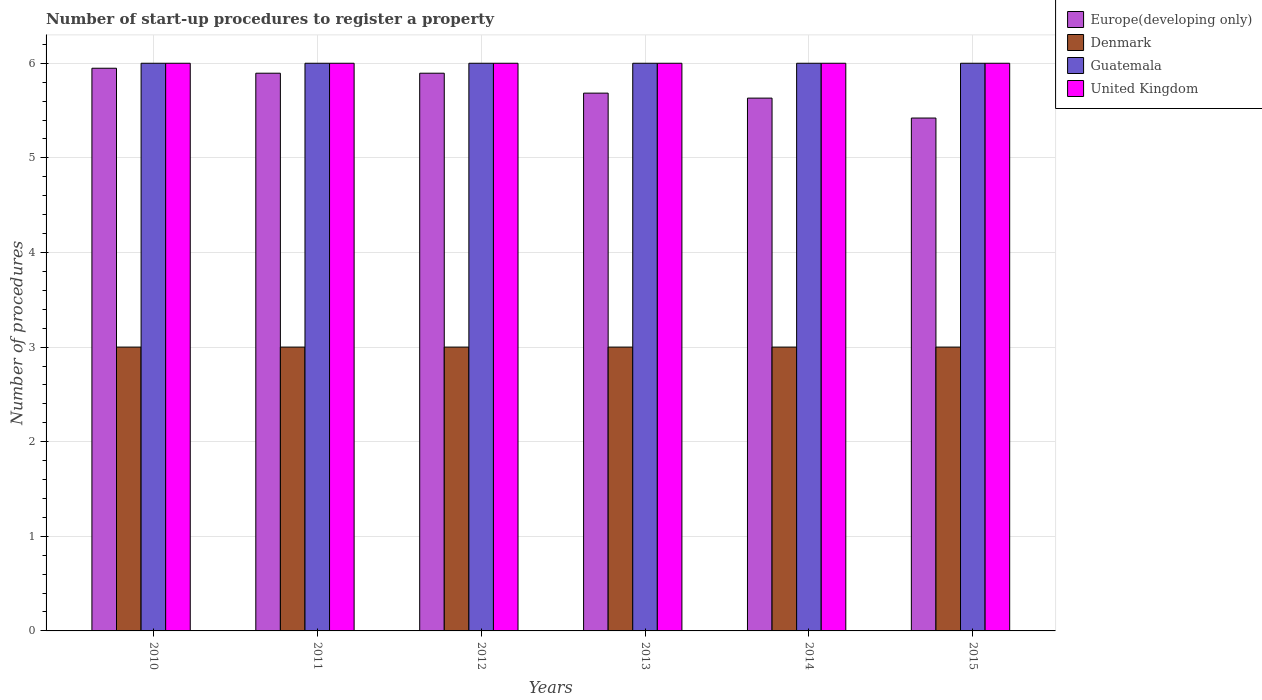How many different coloured bars are there?
Your answer should be very brief. 4. How many groups of bars are there?
Keep it short and to the point. 6. Are the number of bars per tick equal to the number of legend labels?
Ensure brevity in your answer.  Yes. How many bars are there on the 5th tick from the left?
Your answer should be very brief. 4. How many bars are there on the 4th tick from the right?
Provide a short and direct response. 4. In how many cases, is the number of bars for a given year not equal to the number of legend labels?
Provide a short and direct response. 0. What is the number of procedures required to register a property in Denmark in 2012?
Ensure brevity in your answer.  3. Across all years, what is the maximum number of procedures required to register a property in Europe(developing only)?
Your answer should be compact. 5.95. Across all years, what is the minimum number of procedures required to register a property in Europe(developing only)?
Offer a terse response. 5.42. In which year was the number of procedures required to register a property in Guatemala maximum?
Keep it short and to the point. 2010. In which year was the number of procedures required to register a property in Europe(developing only) minimum?
Your answer should be very brief. 2015. What is the total number of procedures required to register a property in Denmark in the graph?
Provide a short and direct response. 18. What is the difference between the number of procedures required to register a property in Europe(developing only) in 2015 and the number of procedures required to register a property in Denmark in 2013?
Your answer should be compact. 2.42. In the year 2010, what is the difference between the number of procedures required to register a property in Denmark and number of procedures required to register a property in Europe(developing only)?
Your answer should be compact. -2.95. What is the ratio of the number of procedures required to register a property in Guatemala in 2012 to that in 2014?
Provide a short and direct response. 1. Is the difference between the number of procedures required to register a property in Denmark in 2013 and 2015 greater than the difference between the number of procedures required to register a property in Europe(developing only) in 2013 and 2015?
Keep it short and to the point. No. What is the difference between the highest and the second highest number of procedures required to register a property in Europe(developing only)?
Your answer should be compact. 0.05. Is the sum of the number of procedures required to register a property in Europe(developing only) in 2011 and 2015 greater than the maximum number of procedures required to register a property in United Kingdom across all years?
Make the answer very short. Yes. Is it the case that in every year, the sum of the number of procedures required to register a property in Guatemala and number of procedures required to register a property in Denmark is greater than the sum of number of procedures required to register a property in Europe(developing only) and number of procedures required to register a property in United Kingdom?
Your answer should be compact. No. What does the 2nd bar from the right in 2014 represents?
Make the answer very short. Guatemala. How many bars are there?
Give a very brief answer. 24. Are all the bars in the graph horizontal?
Ensure brevity in your answer.  No. How many years are there in the graph?
Your answer should be compact. 6. What is the difference between two consecutive major ticks on the Y-axis?
Provide a succinct answer. 1. Does the graph contain any zero values?
Your response must be concise. No. Does the graph contain grids?
Make the answer very short. Yes. How many legend labels are there?
Provide a succinct answer. 4. How are the legend labels stacked?
Provide a short and direct response. Vertical. What is the title of the graph?
Give a very brief answer. Number of start-up procedures to register a property. What is the label or title of the Y-axis?
Provide a short and direct response. Number of procedures. What is the Number of procedures in Europe(developing only) in 2010?
Ensure brevity in your answer.  5.95. What is the Number of procedures of Denmark in 2010?
Ensure brevity in your answer.  3. What is the Number of procedures in Guatemala in 2010?
Give a very brief answer. 6. What is the Number of procedures in United Kingdom in 2010?
Offer a terse response. 6. What is the Number of procedures of Europe(developing only) in 2011?
Your response must be concise. 5.89. What is the Number of procedures of Guatemala in 2011?
Your answer should be very brief. 6. What is the Number of procedures of United Kingdom in 2011?
Keep it short and to the point. 6. What is the Number of procedures in Europe(developing only) in 2012?
Offer a very short reply. 5.89. What is the Number of procedures in Guatemala in 2012?
Your answer should be very brief. 6. What is the Number of procedures in Europe(developing only) in 2013?
Ensure brevity in your answer.  5.68. What is the Number of procedures in Denmark in 2013?
Make the answer very short. 3. What is the Number of procedures of Europe(developing only) in 2014?
Offer a terse response. 5.63. What is the Number of procedures in United Kingdom in 2014?
Your response must be concise. 6. What is the Number of procedures of Europe(developing only) in 2015?
Make the answer very short. 5.42. What is the Number of procedures in Denmark in 2015?
Your response must be concise. 3. Across all years, what is the maximum Number of procedures in Europe(developing only)?
Provide a short and direct response. 5.95. Across all years, what is the maximum Number of procedures in Guatemala?
Your answer should be very brief. 6. Across all years, what is the maximum Number of procedures of United Kingdom?
Make the answer very short. 6. Across all years, what is the minimum Number of procedures in Europe(developing only)?
Provide a short and direct response. 5.42. Across all years, what is the minimum Number of procedures of Guatemala?
Your response must be concise. 6. Across all years, what is the minimum Number of procedures in United Kingdom?
Your response must be concise. 6. What is the total Number of procedures of Europe(developing only) in the graph?
Your answer should be very brief. 34.47. What is the total Number of procedures in Denmark in the graph?
Ensure brevity in your answer.  18. What is the total Number of procedures of Guatemala in the graph?
Offer a very short reply. 36. What is the total Number of procedures in United Kingdom in the graph?
Make the answer very short. 36. What is the difference between the Number of procedures in Europe(developing only) in 2010 and that in 2011?
Provide a short and direct response. 0.05. What is the difference between the Number of procedures of Guatemala in 2010 and that in 2011?
Offer a very short reply. 0. What is the difference between the Number of procedures of Europe(developing only) in 2010 and that in 2012?
Ensure brevity in your answer.  0.05. What is the difference between the Number of procedures of United Kingdom in 2010 and that in 2012?
Your answer should be very brief. 0. What is the difference between the Number of procedures of Europe(developing only) in 2010 and that in 2013?
Provide a succinct answer. 0.26. What is the difference between the Number of procedures in Denmark in 2010 and that in 2013?
Offer a very short reply. 0. What is the difference between the Number of procedures of Europe(developing only) in 2010 and that in 2014?
Offer a terse response. 0.32. What is the difference between the Number of procedures in Denmark in 2010 and that in 2014?
Provide a short and direct response. 0. What is the difference between the Number of procedures in Guatemala in 2010 and that in 2014?
Offer a very short reply. 0. What is the difference between the Number of procedures in United Kingdom in 2010 and that in 2014?
Provide a short and direct response. 0. What is the difference between the Number of procedures in Europe(developing only) in 2010 and that in 2015?
Your response must be concise. 0.53. What is the difference between the Number of procedures in Denmark in 2010 and that in 2015?
Make the answer very short. 0. What is the difference between the Number of procedures in Guatemala in 2010 and that in 2015?
Your response must be concise. 0. What is the difference between the Number of procedures in Denmark in 2011 and that in 2012?
Ensure brevity in your answer.  0. What is the difference between the Number of procedures in Guatemala in 2011 and that in 2012?
Your answer should be compact. 0. What is the difference between the Number of procedures of United Kingdom in 2011 and that in 2012?
Give a very brief answer. 0. What is the difference between the Number of procedures in Europe(developing only) in 2011 and that in 2013?
Ensure brevity in your answer.  0.21. What is the difference between the Number of procedures of Guatemala in 2011 and that in 2013?
Ensure brevity in your answer.  0. What is the difference between the Number of procedures of United Kingdom in 2011 and that in 2013?
Give a very brief answer. 0. What is the difference between the Number of procedures in Europe(developing only) in 2011 and that in 2014?
Give a very brief answer. 0.26. What is the difference between the Number of procedures in Denmark in 2011 and that in 2014?
Ensure brevity in your answer.  0. What is the difference between the Number of procedures in Guatemala in 2011 and that in 2014?
Make the answer very short. 0. What is the difference between the Number of procedures in Europe(developing only) in 2011 and that in 2015?
Give a very brief answer. 0.47. What is the difference between the Number of procedures of Guatemala in 2011 and that in 2015?
Make the answer very short. 0. What is the difference between the Number of procedures of Europe(developing only) in 2012 and that in 2013?
Your answer should be compact. 0.21. What is the difference between the Number of procedures in Europe(developing only) in 2012 and that in 2014?
Ensure brevity in your answer.  0.26. What is the difference between the Number of procedures of Denmark in 2012 and that in 2014?
Provide a short and direct response. 0. What is the difference between the Number of procedures in Guatemala in 2012 and that in 2014?
Your response must be concise. 0. What is the difference between the Number of procedures in United Kingdom in 2012 and that in 2014?
Your answer should be compact. 0. What is the difference between the Number of procedures in Europe(developing only) in 2012 and that in 2015?
Make the answer very short. 0.47. What is the difference between the Number of procedures of United Kingdom in 2012 and that in 2015?
Your answer should be very brief. 0. What is the difference between the Number of procedures of Europe(developing only) in 2013 and that in 2014?
Your answer should be very brief. 0.05. What is the difference between the Number of procedures of Denmark in 2013 and that in 2014?
Give a very brief answer. 0. What is the difference between the Number of procedures in United Kingdom in 2013 and that in 2014?
Provide a short and direct response. 0. What is the difference between the Number of procedures of Europe(developing only) in 2013 and that in 2015?
Provide a short and direct response. 0.26. What is the difference between the Number of procedures in Guatemala in 2013 and that in 2015?
Give a very brief answer. 0. What is the difference between the Number of procedures of Europe(developing only) in 2014 and that in 2015?
Give a very brief answer. 0.21. What is the difference between the Number of procedures of Denmark in 2014 and that in 2015?
Give a very brief answer. 0. What is the difference between the Number of procedures of Europe(developing only) in 2010 and the Number of procedures of Denmark in 2011?
Make the answer very short. 2.95. What is the difference between the Number of procedures in Europe(developing only) in 2010 and the Number of procedures in Guatemala in 2011?
Your answer should be very brief. -0.05. What is the difference between the Number of procedures of Europe(developing only) in 2010 and the Number of procedures of United Kingdom in 2011?
Provide a short and direct response. -0.05. What is the difference between the Number of procedures of Denmark in 2010 and the Number of procedures of United Kingdom in 2011?
Your answer should be compact. -3. What is the difference between the Number of procedures of Europe(developing only) in 2010 and the Number of procedures of Denmark in 2012?
Offer a very short reply. 2.95. What is the difference between the Number of procedures in Europe(developing only) in 2010 and the Number of procedures in Guatemala in 2012?
Offer a very short reply. -0.05. What is the difference between the Number of procedures of Europe(developing only) in 2010 and the Number of procedures of United Kingdom in 2012?
Ensure brevity in your answer.  -0.05. What is the difference between the Number of procedures in Europe(developing only) in 2010 and the Number of procedures in Denmark in 2013?
Your response must be concise. 2.95. What is the difference between the Number of procedures of Europe(developing only) in 2010 and the Number of procedures of Guatemala in 2013?
Your response must be concise. -0.05. What is the difference between the Number of procedures in Europe(developing only) in 2010 and the Number of procedures in United Kingdom in 2013?
Your answer should be very brief. -0.05. What is the difference between the Number of procedures of Denmark in 2010 and the Number of procedures of United Kingdom in 2013?
Your answer should be very brief. -3. What is the difference between the Number of procedures in Guatemala in 2010 and the Number of procedures in United Kingdom in 2013?
Offer a terse response. 0. What is the difference between the Number of procedures in Europe(developing only) in 2010 and the Number of procedures in Denmark in 2014?
Your answer should be compact. 2.95. What is the difference between the Number of procedures in Europe(developing only) in 2010 and the Number of procedures in Guatemala in 2014?
Your response must be concise. -0.05. What is the difference between the Number of procedures in Europe(developing only) in 2010 and the Number of procedures in United Kingdom in 2014?
Give a very brief answer. -0.05. What is the difference between the Number of procedures of Denmark in 2010 and the Number of procedures of United Kingdom in 2014?
Provide a short and direct response. -3. What is the difference between the Number of procedures of Europe(developing only) in 2010 and the Number of procedures of Denmark in 2015?
Provide a succinct answer. 2.95. What is the difference between the Number of procedures of Europe(developing only) in 2010 and the Number of procedures of Guatemala in 2015?
Ensure brevity in your answer.  -0.05. What is the difference between the Number of procedures of Europe(developing only) in 2010 and the Number of procedures of United Kingdom in 2015?
Ensure brevity in your answer.  -0.05. What is the difference between the Number of procedures in Denmark in 2010 and the Number of procedures in United Kingdom in 2015?
Keep it short and to the point. -3. What is the difference between the Number of procedures of Guatemala in 2010 and the Number of procedures of United Kingdom in 2015?
Provide a short and direct response. 0. What is the difference between the Number of procedures in Europe(developing only) in 2011 and the Number of procedures in Denmark in 2012?
Your response must be concise. 2.89. What is the difference between the Number of procedures of Europe(developing only) in 2011 and the Number of procedures of Guatemala in 2012?
Offer a very short reply. -0.11. What is the difference between the Number of procedures in Europe(developing only) in 2011 and the Number of procedures in United Kingdom in 2012?
Make the answer very short. -0.11. What is the difference between the Number of procedures in Denmark in 2011 and the Number of procedures in Guatemala in 2012?
Your answer should be very brief. -3. What is the difference between the Number of procedures in Europe(developing only) in 2011 and the Number of procedures in Denmark in 2013?
Keep it short and to the point. 2.89. What is the difference between the Number of procedures in Europe(developing only) in 2011 and the Number of procedures in Guatemala in 2013?
Your response must be concise. -0.11. What is the difference between the Number of procedures of Europe(developing only) in 2011 and the Number of procedures of United Kingdom in 2013?
Keep it short and to the point. -0.11. What is the difference between the Number of procedures of Denmark in 2011 and the Number of procedures of Guatemala in 2013?
Your answer should be very brief. -3. What is the difference between the Number of procedures in Denmark in 2011 and the Number of procedures in United Kingdom in 2013?
Your answer should be very brief. -3. What is the difference between the Number of procedures of Guatemala in 2011 and the Number of procedures of United Kingdom in 2013?
Your response must be concise. 0. What is the difference between the Number of procedures in Europe(developing only) in 2011 and the Number of procedures in Denmark in 2014?
Ensure brevity in your answer.  2.89. What is the difference between the Number of procedures in Europe(developing only) in 2011 and the Number of procedures in Guatemala in 2014?
Make the answer very short. -0.11. What is the difference between the Number of procedures of Europe(developing only) in 2011 and the Number of procedures of United Kingdom in 2014?
Keep it short and to the point. -0.11. What is the difference between the Number of procedures of Denmark in 2011 and the Number of procedures of Guatemala in 2014?
Provide a short and direct response. -3. What is the difference between the Number of procedures of Denmark in 2011 and the Number of procedures of United Kingdom in 2014?
Give a very brief answer. -3. What is the difference between the Number of procedures in Europe(developing only) in 2011 and the Number of procedures in Denmark in 2015?
Your answer should be compact. 2.89. What is the difference between the Number of procedures in Europe(developing only) in 2011 and the Number of procedures in Guatemala in 2015?
Offer a very short reply. -0.11. What is the difference between the Number of procedures in Europe(developing only) in 2011 and the Number of procedures in United Kingdom in 2015?
Give a very brief answer. -0.11. What is the difference between the Number of procedures of Denmark in 2011 and the Number of procedures of United Kingdom in 2015?
Your response must be concise. -3. What is the difference between the Number of procedures of Guatemala in 2011 and the Number of procedures of United Kingdom in 2015?
Provide a succinct answer. 0. What is the difference between the Number of procedures in Europe(developing only) in 2012 and the Number of procedures in Denmark in 2013?
Provide a succinct answer. 2.89. What is the difference between the Number of procedures in Europe(developing only) in 2012 and the Number of procedures in Guatemala in 2013?
Your answer should be compact. -0.11. What is the difference between the Number of procedures in Europe(developing only) in 2012 and the Number of procedures in United Kingdom in 2013?
Offer a terse response. -0.11. What is the difference between the Number of procedures of Denmark in 2012 and the Number of procedures of Guatemala in 2013?
Give a very brief answer. -3. What is the difference between the Number of procedures in Guatemala in 2012 and the Number of procedures in United Kingdom in 2013?
Make the answer very short. 0. What is the difference between the Number of procedures of Europe(developing only) in 2012 and the Number of procedures of Denmark in 2014?
Offer a very short reply. 2.89. What is the difference between the Number of procedures of Europe(developing only) in 2012 and the Number of procedures of Guatemala in 2014?
Offer a terse response. -0.11. What is the difference between the Number of procedures of Europe(developing only) in 2012 and the Number of procedures of United Kingdom in 2014?
Your answer should be compact. -0.11. What is the difference between the Number of procedures of Denmark in 2012 and the Number of procedures of Guatemala in 2014?
Make the answer very short. -3. What is the difference between the Number of procedures in Guatemala in 2012 and the Number of procedures in United Kingdom in 2014?
Offer a very short reply. 0. What is the difference between the Number of procedures of Europe(developing only) in 2012 and the Number of procedures of Denmark in 2015?
Your answer should be compact. 2.89. What is the difference between the Number of procedures in Europe(developing only) in 2012 and the Number of procedures in Guatemala in 2015?
Ensure brevity in your answer.  -0.11. What is the difference between the Number of procedures of Europe(developing only) in 2012 and the Number of procedures of United Kingdom in 2015?
Provide a short and direct response. -0.11. What is the difference between the Number of procedures in Denmark in 2012 and the Number of procedures in Guatemala in 2015?
Offer a terse response. -3. What is the difference between the Number of procedures in Europe(developing only) in 2013 and the Number of procedures in Denmark in 2014?
Ensure brevity in your answer.  2.68. What is the difference between the Number of procedures of Europe(developing only) in 2013 and the Number of procedures of Guatemala in 2014?
Keep it short and to the point. -0.32. What is the difference between the Number of procedures of Europe(developing only) in 2013 and the Number of procedures of United Kingdom in 2014?
Ensure brevity in your answer.  -0.32. What is the difference between the Number of procedures in Denmark in 2013 and the Number of procedures in United Kingdom in 2014?
Give a very brief answer. -3. What is the difference between the Number of procedures in Europe(developing only) in 2013 and the Number of procedures in Denmark in 2015?
Ensure brevity in your answer.  2.68. What is the difference between the Number of procedures in Europe(developing only) in 2013 and the Number of procedures in Guatemala in 2015?
Offer a very short reply. -0.32. What is the difference between the Number of procedures of Europe(developing only) in 2013 and the Number of procedures of United Kingdom in 2015?
Offer a terse response. -0.32. What is the difference between the Number of procedures in Denmark in 2013 and the Number of procedures in Guatemala in 2015?
Keep it short and to the point. -3. What is the difference between the Number of procedures of Denmark in 2013 and the Number of procedures of United Kingdom in 2015?
Ensure brevity in your answer.  -3. What is the difference between the Number of procedures of Europe(developing only) in 2014 and the Number of procedures of Denmark in 2015?
Provide a succinct answer. 2.63. What is the difference between the Number of procedures of Europe(developing only) in 2014 and the Number of procedures of Guatemala in 2015?
Give a very brief answer. -0.37. What is the difference between the Number of procedures in Europe(developing only) in 2014 and the Number of procedures in United Kingdom in 2015?
Give a very brief answer. -0.37. What is the difference between the Number of procedures in Guatemala in 2014 and the Number of procedures in United Kingdom in 2015?
Make the answer very short. 0. What is the average Number of procedures of Europe(developing only) per year?
Make the answer very short. 5.75. What is the average Number of procedures of Guatemala per year?
Your answer should be very brief. 6. What is the average Number of procedures of United Kingdom per year?
Offer a terse response. 6. In the year 2010, what is the difference between the Number of procedures of Europe(developing only) and Number of procedures of Denmark?
Your answer should be very brief. 2.95. In the year 2010, what is the difference between the Number of procedures of Europe(developing only) and Number of procedures of Guatemala?
Provide a short and direct response. -0.05. In the year 2010, what is the difference between the Number of procedures of Europe(developing only) and Number of procedures of United Kingdom?
Offer a terse response. -0.05. In the year 2010, what is the difference between the Number of procedures in Denmark and Number of procedures in Guatemala?
Provide a succinct answer. -3. In the year 2010, what is the difference between the Number of procedures in Denmark and Number of procedures in United Kingdom?
Give a very brief answer. -3. In the year 2010, what is the difference between the Number of procedures in Guatemala and Number of procedures in United Kingdom?
Offer a very short reply. 0. In the year 2011, what is the difference between the Number of procedures of Europe(developing only) and Number of procedures of Denmark?
Your answer should be very brief. 2.89. In the year 2011, what is the difference between the Number of procedures of Europe(developing only) and Number of procedures of Guatemala?
Keep it short and to the point. -0.11. In the year 2011, what is the difference between the Number of procedures in Europe(developing only) and Number of procedures in United Kingdom?
Make the answer very short. -0.11. In the year 2012, what is the difference between the Number of procedures of Europe(developing only) and Number of procedures of Denmark?
Keep it short and to the point. 2.89. In the year 2012, what is the difference between the Number of procedures of Europe(developing only) and Number of procedures of Guatemala?
Make the answer very short. -0.11. In the year 2012, what is the difference between the Number of procedures in Europe(developing only) and Number of procedures in United Kingdom?
Keep it short and to the point. -0.11. In the year 2012, what is the difference between the Number of procedures in Denmark and Number of procedures in United Kingdom?
Your answer should be compact. -3. In the year 2013, what is the difference between the Number of procedures in Europe(developing only) and Number of procedures in Denmark?
Your answer should be compact. 2.68. In the year 2013, what is the difference between the Number of procedures of Europe(developing only) and Number of procedures of Guatemala?
Offer a very short reply. -0.32. In the year 2013, what is the difference between the Number of procedures of Europe(developing only) and Number of procedures of United Kingdom?
Your response must be concise. -0.32. In the year 2013, what is the difference between the Number of procedures in Denmark and Number of procedures in Guatemala?
Keep it short and to the point. -3. In the year 2013, what is the difference between the Number of procedures of Denmark and Number of procedures of United Kingdom?
Your answer should be compact. -3. In the year 2013, what is the difference between the Number of procedures of Guatemala and Number of procedures of United Kingdom?
Keep it short and to the point. 0. In the year 2014, what is the difference between the Number of procedures of Europe(developing only) and Number of procedures of Denmark?
Ensure brevity in your answer.  2.63. In the year 2014, what is the difference between the Number of procedures of Europe(developing only) and Number of procedures of Guatemala?
Make the answer very short. -0.37. In the year 2014, what is the difference between the Number of procedures of Europe(developing only) and Number of procedures of United Kingdom?
Ensure brevity in your answer.  -0.37. In the year 2014, what is the difference between the Number of procedures in Denmark and Number of procedures in United Kingdom?
Make the answer very short. -3. In the year 2014, what is the difference between the Number of procedures in Guatemala and Number of procedures in United Kingdom?
Provide a succinct answer. 0. In the year 2015, what is the difference between the Number of procedures of Europe(developing only) and Number of procedures of Denmark?
Make the answer very short. 2.42. In the year 2015, what is the difference between the Number of procedures of Europe(developing only) and Number of procedures of Guatemala?
Provide a succinct answer. -0.58. In the year 2015, what is the difference between the Number of procedures in Europe(developing only) and Number of procedures in United Kingdom?
Provide a succinct answer. -0.58. In the year 2015, what is the difference between the Number of procedures of Denmark and Number of procedures of Guatemala?
Your response must be concise. -3. What is the ratio of the Number of procedures in Europe(developing only) in 2010 to that in 2011?
Your response must be concise. 1.01. What is the ratio of the Number of procedures in Guatemala in 2010 to that in 2011?
Give a very brief answer. 1. What is the ratio of the Number of procedures in United Kingdom in 2010 to that in 2011?
Your response must be concise. 1. What is the ratio of the Number of procedures of Europe(developing only) in 2010 to that in 2012?
Give a very brief answer. 1.01. What is the ratio of the Number of procedures of Guatemala in 2010 to that in 2012?
Provide a succinct answer. 1. What is the ratio of the Number of procedures of United Kingdom in 2010 to that in 2012?
Your response must be concise. 1. What is the ratio of the Number of procedures of Europe(developing only) in 2010 to that in 2013?
Give a very brief answer. 1.05. What is the ratio of the Number of procedures in Europe(developing only) in 2010 to that in 2014?
Offer a terse response. 1.06. What is the ratio of the Number of procedures in United Kingdom in 2010 to that in 2014?
Make the answer very short. 1. What is the ratio of the Number of procedures in Europe(developing only) in 2010 to that in 2015?
Make the answer very short. 1.1. What is the ratio of the Number of procedures of Denmark in 2010 to that in 2015?
Your answer should be very brief. 1. What is the ratio of the Number of procedures in Guatemala in 2010 to that in 2015?
Provide a succinct answer. 1. What is the ratio of the Number of procedures of United Kingdom in 2010 to that in 2015?
Offer a terse response. 1. What is the ratio of the Number of procedures of Europe(developing only) in 2011 to that in 2012?
Offer a very short reply. 1. What is the ratio of the Number of procedures in Denmark in 2011 to that in 2012?
Offer a terse response. 1. What is the ratio of the Number of procedures of United Kingdom in 2011 to that in 2012?
Provide a succinct answer. 1. What is the ratio of the Number of procedures in Europe(developing only) in 2011 to that in 2013?
Offer a very short reply. 1.04. What is the ratio of the Number of procedures of Denmark in 2011 to that in 2013?
Ensure brevity in your answer.  1. What is the ratio of the Number of procedures of United Kingdom in 2011 to that in 2013?
Provide a short and direct response. 1. What is the ratio of the Number of procedures of Europe(developing only) in 2011 to that in 2014?
Give a very brief answer. 1.05. What is the ratio of the Number of procedures of Denmark in 2011 to that in 2014?
Make the answer very short. 1. What is the ratio of the Number of procedures in Europe(developing only) in 2011 to that in 2015?
Make the answer very short. 1.09. What is the ratio of the Number of procedures of Denmark in 2011 to that in 2015?
Your response must be concise. 1. What is the ratio of the Number of procedures of Guatemala in 2011 to that in 2015?
Your answer should be compact. 1. What is the ratio of the Number of procedures in United Kingdom in 2011 to that in 2015?
Your answer should be very brief. 1. What is the ratio of the Number of procedures of Europe(developing only) in 2012 to that in 2013?
Provide a succinct answer. 1.04. What is the ratio of the Number of procedures in United Kingdom in 2012 to that in 2013?
Make the answer very short. 1. What is the ratio of the Number of procedures in Europe(developing only) in 2012 to that in 2014?
Give a very brief answer. 1.05. What is the ratio of the Number of procedures of Denmark in 2012 to that in 2014?
Offer a very short reply. 1. What is the ratio of the Number of procedures in Guatemala in 2012 to that in 2014?
Offer a very short reply. 1. What is the ratio of the Number of procedures in Europe(developing only) in 2012 to that in 2015?
Your answer should be very brief. 1.09. What is the ratio of the Number of procedures of Denmark in 2012 to that in 2015?
Ensure brevity in your answer.  1. What is the ratio of the Number of procedures in Europe(developing only) in 2013 to that in 2014?
Offer a very short reply. 1.01. What is the ratio of the Number of procedures in Denmark in 2013 to that in 2014?
Keep it short and to the point. 1. What is the ratio of the Number of procedures in Guatemala in 2013 to that in 2014?
Offer a terse response. 1. What is the ratio of the Number of procedures in Europe(developing only) in 2013 to that in 2015?
Ensure brevity in your answer.  1.05. What is the ratio of the Number of procedures in Europe(developing only) in 2014 to that in 2015?
Keep it short and to the point. 1.04. What is the ratio of the Number of procedures in Denmark in 2014 to that in 2015?
Provide a short and direct response. 1. What is the ratio of the Number of procedures of Guatemala in 2014 to that in 2015?
Your answer should be very brief. 1. What is the ratio of the Number of procedures of United Kingdom in 2014 to that in 2015?
Keep it short and to the point. 1. What is the difference between the highest and the second highest Number of procedures of Europe(developing only)?
Offer a very short reply. 0.05. What is the difference between the highest and the second highest Number of procedures of Denmark?
Offer a very short reply. 0. What is the difference between the highest and the second highest Number of procedures in Guatemala?
Offer a terse response. 0. What is the difference between the highest and the second highest Number of procedures of United Kingdom?
Your answer should be compact. 0. What is the difference between the highest and the lowest Number of procedures in Europe(developing only)?
Offer a terse response. 0.53. 